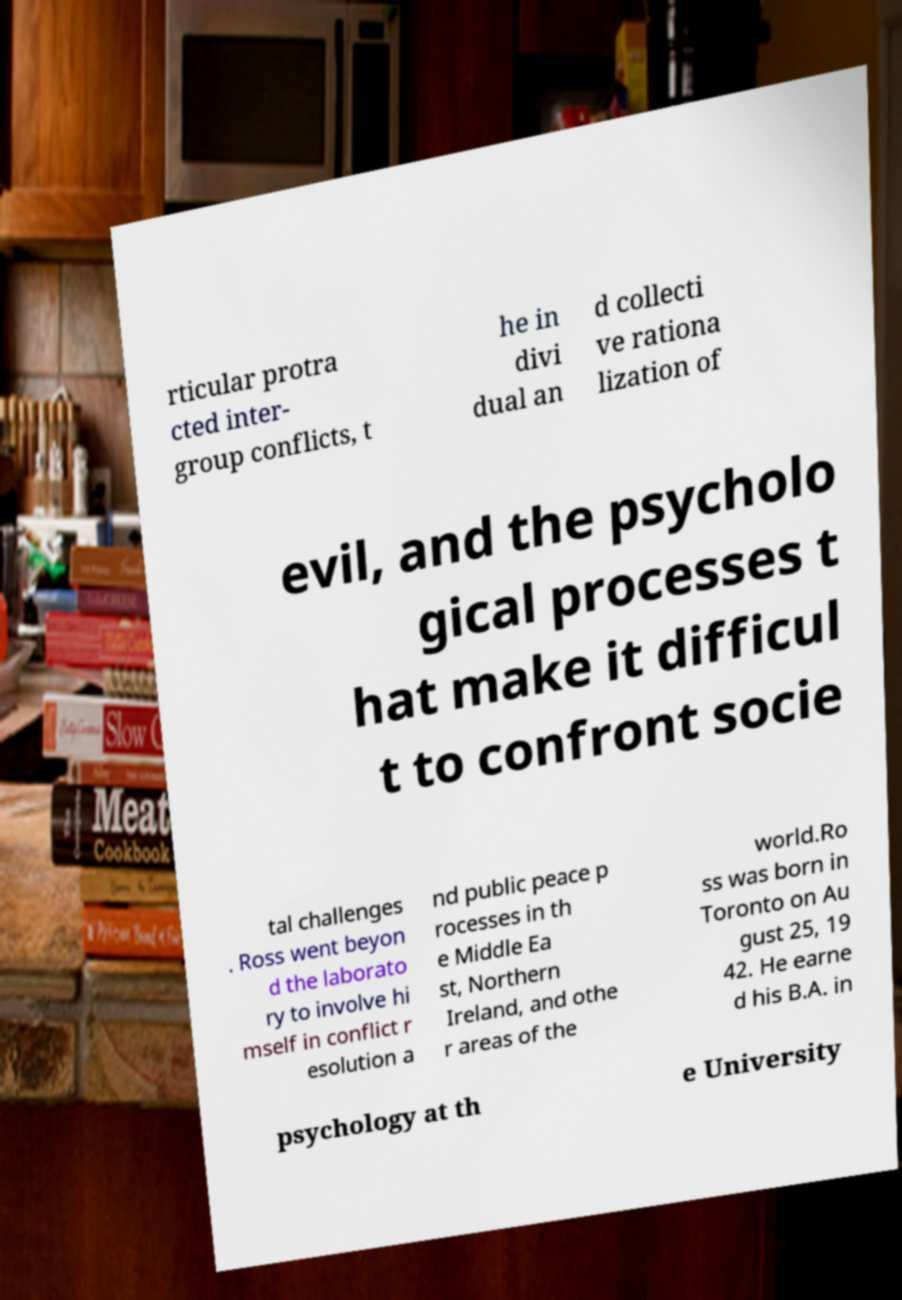Please identify and transcribe the text found in this image. rticular protra cted inter- group conflicts, t he in divi dual an d collecti ve rationa lization of evil, and the psycholo gical processes t hat make it difficul t to confront socie tal challenges . Ross went beyon d the laborato ry to involve hi mself in conflict r esolution a nd public peace p rocesses in th e Middle Ea st, Northern Ireland, and othe r areas of the world.Ro ss was born in Toronto on Au gust 25, 19 42. He earne d his B.A. in psychology at th e University 